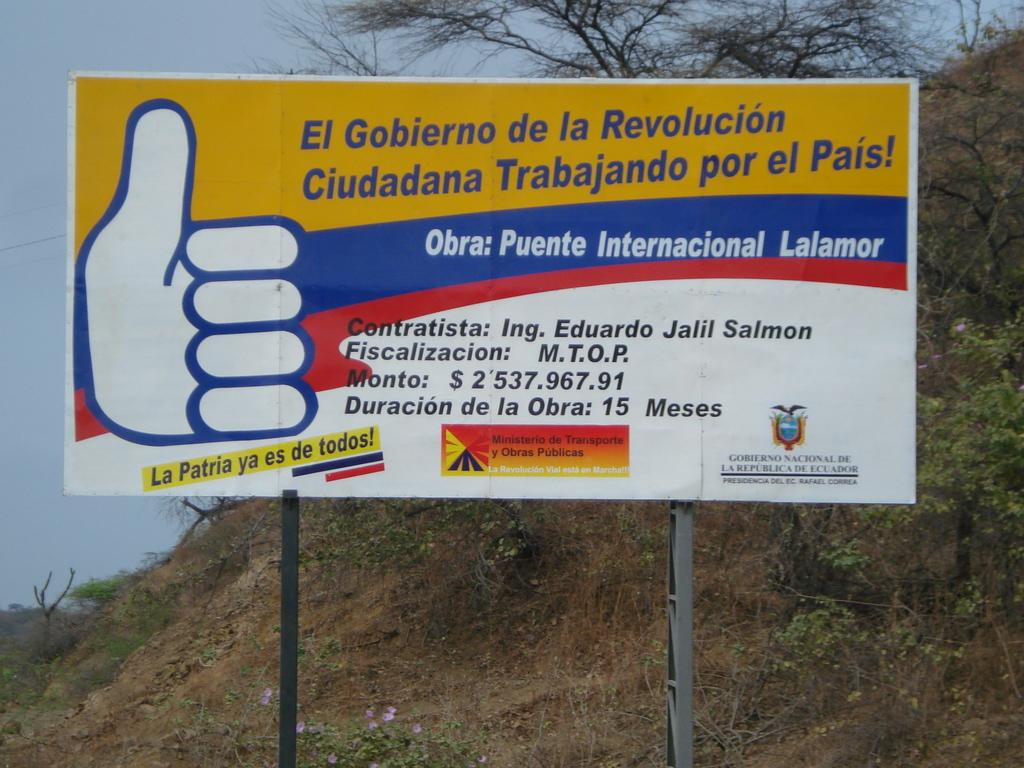<image>
Create a compact narrative representing the image presented. A Spanish billboard in Ecuador on the side of a hill that has a big thumbs up sign. 